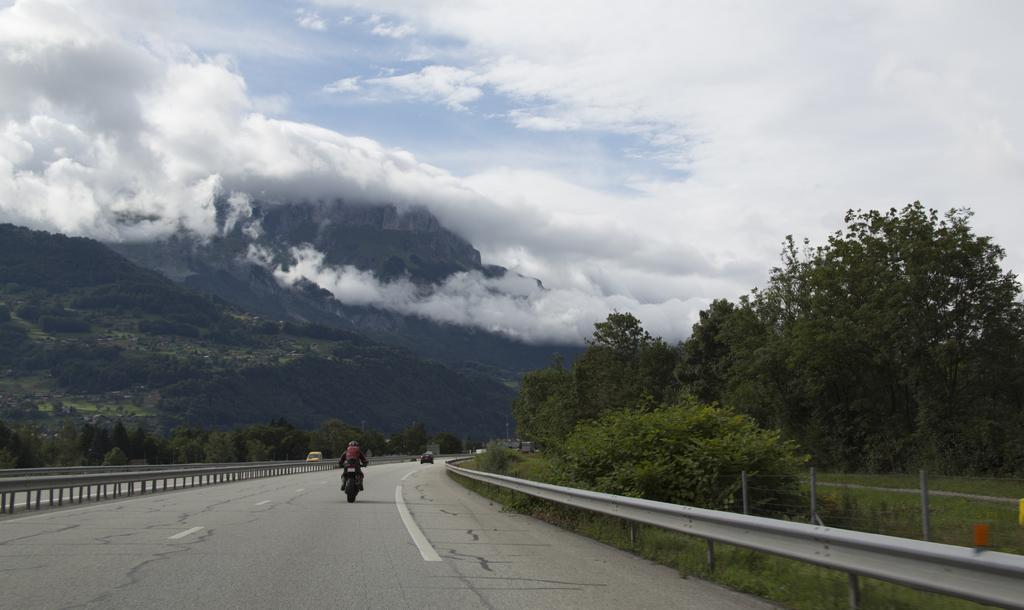What is happening on the road in the image? There are vehicles moving on the road in the image. What can be seen alongside the road? There is a fence visible in the image. What type of natural elements are present in the image? There are trees in the image. What can be seen in the distance in the image? There are hills in the background of the image. What is visible in the sky in the image? The sky is visible in the background of the image, and clouds are present. Can you see a coach carrying passengers in the image? There is no coach carrying passengers visible in the image. Are there any snakes slithering on the road in the image? There are no snakes present in the image. 